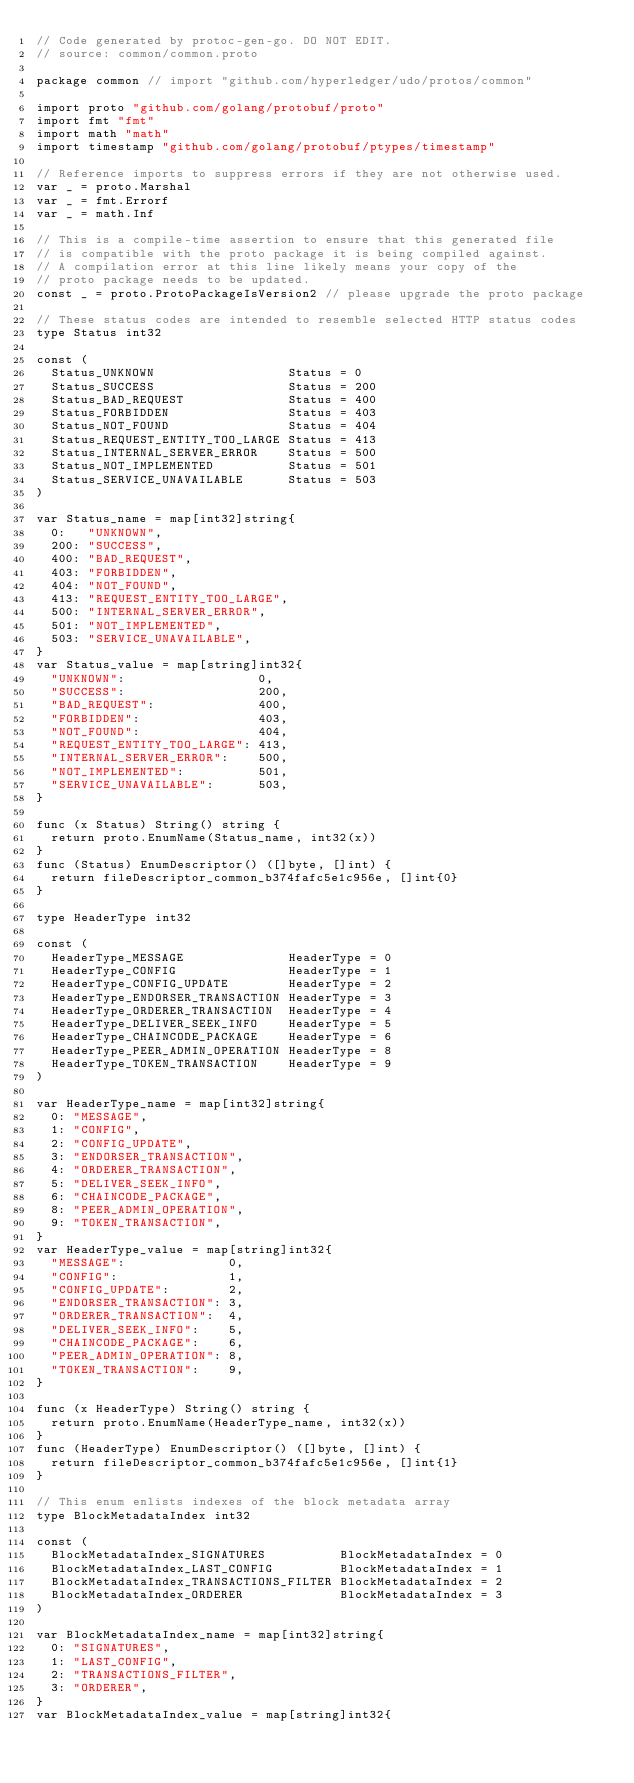<code> <loc_0><loc_0><loc_500><loc_500><_Go_>// Code generated by protoc-gen-go. DO NOT EDIT.
// source: common/common.proto

package common // import "github.com/hyperledger/udo/protos/common"

import proto "github.com/golang/protobuf/proto"
import fmt "fmt"
import math "math"
import timestamp "github.com/golang/protobuf/ptypes/timestamp"

// Reference imports to suppress errors if they are not otherwise used.
var _ = proto.Marshal
var _ = fmt.Errorf
var _ = math.Inf

// This is a compile-time assertion to ensure that this generated file
// is compatible with the proto package it is being compiled against.
// A compilation error at this line likely means your copy of the
// proto package needs to be updated.
const _ = proto.ProtoPackageIsVersion2 // please upgrade the proto package

// These status codes are intended to resemble selected HTTP status codes
type Status int32

const (
	Status_UNKNOWN                  Status = 0
	Status_SUCCESS                  Status = 200
	Status_BAD_REQUEST              Status = 400
	Status_FORBIDDEN                Status = 403
	Status_NOT_FOUND                Status = 404
	Status_REQUEST_ENTITY_TOO_LARGE Status = 413
	Status_INTERNAL_SERVER_ERROR    Status = 500
	Status_NOT_IMPLEMENTED          Status = 501
	Status_SERVICE_UNAVAILABLE      Status = 503
)

var Status_name = map[int32]string{
	0:   "UNKNOWN",
	200: "SUCCESS",
	400: "BAD_REQUEST",
	403: "FORBIDDEN",
	404: "NOT_FOUND",
	413: "REQUEST_ENTITY_TOO_LARGE",
	500: "INTERNAL_SERVER_ERROR",
	501: "NOT_IMPLEMENTED",
	503: "SERVICE_UNAVAILABLE",
}
var Status_value = map[string]int32{
	"UNKNOWN":                  0,
	"SUCCESS":                  200,
	"BAD_REQUEST":              400,
	"FORBIDDEN":                403,
	"NOT_FOUND":                404,
	"REQUEST_ENTITY_TOO_LARGE": 413,
	"INTERNAL_SERVER_ERROR":    500,
	"NOT_IMPLEMENTED":          501,
	"SERVICE_UNAVAILABLE":      503,
}

func (x Status) String() string {
	return proto.EnumName(Status_name, int32(x))
}
func (Status) EnumDescriptor() ([]byte, []int) {
	return fileDescriptor_common_b374fafc5e1c956e, []int{0}
}

type HeaderType int32

const (
	HeaderType_MESSAGE              HeaderType = 0
	HeaderType_CONFIG               HeaderType = 1
	HeaderType_CONFIG_UPDATE        HeaderType = 2
	HeaderType_ENDORSER_TRANSACTION HeaderType = 3
	HeaderType_ORDERER_TRANSACTION  HeaderType = 4
	HeaderType_DELIVER_SEEK_INFO    HeaderType = 5
	HeaderType_CHAINCODE_PACKAGE    HeaderType = 6
	HeaderType_PEER_ADMIN_OPERATION HeaderType = 8
	HeaderType_TOKEN_TRANSACTION    HeaderType = 9
)

var HeaderType_name = map[int32]string{
	0: "MESSAGE",
	1: "CONFIG",
	2: "CONFIG_UPDATE",
	3: "ENDORSER_TRANSACTION",
	4: "ORDERER_TRANSACTION",
	5: "DELIVER_SEEK_INFO",
	6: "CHAINCODE_PACKAGE",
	8: "PEER_ADMIN_OPERATION",
	9: "TOKEN_TRANSACTION",
}
var HeaderType_value = map[string]int32{
	"MESSAGE":              0,
	"CONFIG":               1,
	"CONFIG_UPDATE":        2,
	"ENDORSER_TRANSACTION": 3,
	"ORDERER_TRANSACTION":  4,
	"DELIVER_SEEK_INFO":    5,
	"CHAINCODE_PACKAGE":    6,
	"PEER_ADMIN_OPERATION": 8,
	"TOKEN_TRANSACTION":    9,
}

func (x HeaderType) String() string {
	return proto.EnumName(HeaderType_name, int32(x))
}
func (HeaderType) EnumDescriptor() ([]byte, []int) {
	return fileDescriptor_common_b374fafc5e1c956e, []int{1}
}

// This enum enlists indexes of the block metadata array
type BlockMetadataIndex int32

const (
	BlockMetadataIndex_SIGNATURES          BlockMetadataIndex = 0
	BlockMetadataIndex_LAST_CONFIG         BlockMetadataIndex = 1
	BlockMetadataIndex_TRANSACTIONS_FILTER BlockMetadataIndex = 2
	BlockMetadataIndex_ORDERER             BlockMetadataIndex = 3
)

var BlockMetadataIndex_name = map[int32]string{
	0: "SIGNATURES",
	1: "LAST_CONFIG",
	2: "TRANSACTIONS_FILTER",
	3: "ORDERER",
}
var BlockMetadataIndex_value = map[string]int32{</code> 